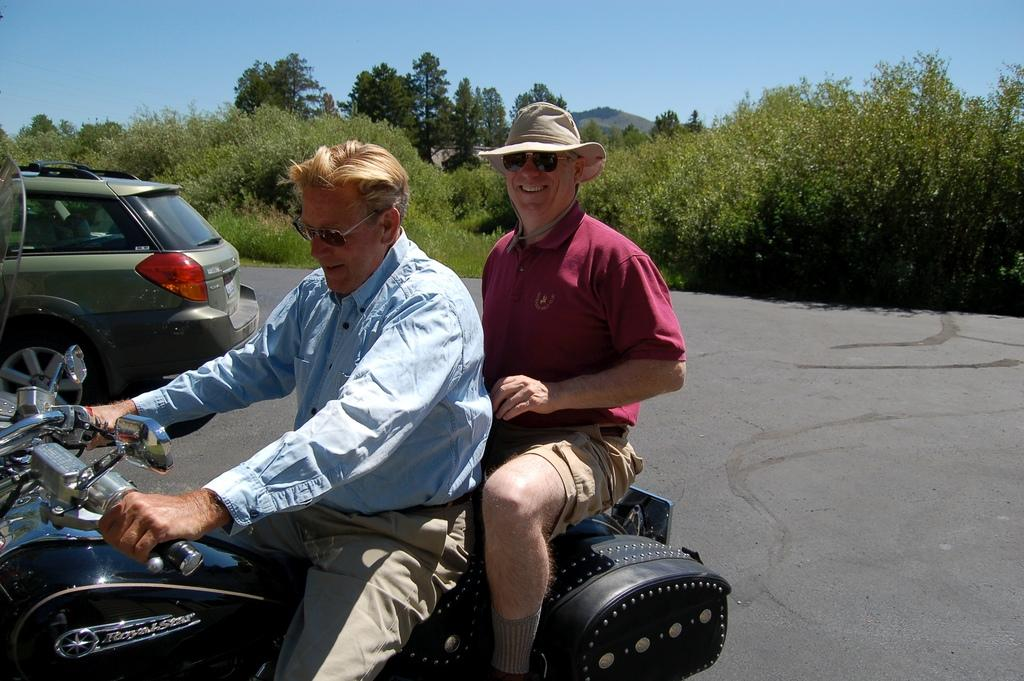What is the main subject of the image? There is a man riding a motorcycle in the image. Is there anyone else with the man on the motorcycle? Yes, there is a person sitting on the back of the motorcycle. What other vehicle can be seen in the image? There is a car parked in the image. What can be seen in the background of the image? There are trees visible in the background of the image. What type of mailbox is present near the parked car in the image? There is no mailbox present in the image. What is the current temperature in the image? The image does not provide information about the temperature; it only shows a man riding a motorcycle, a person sitting on the back, a parked car, and trees in the background. 